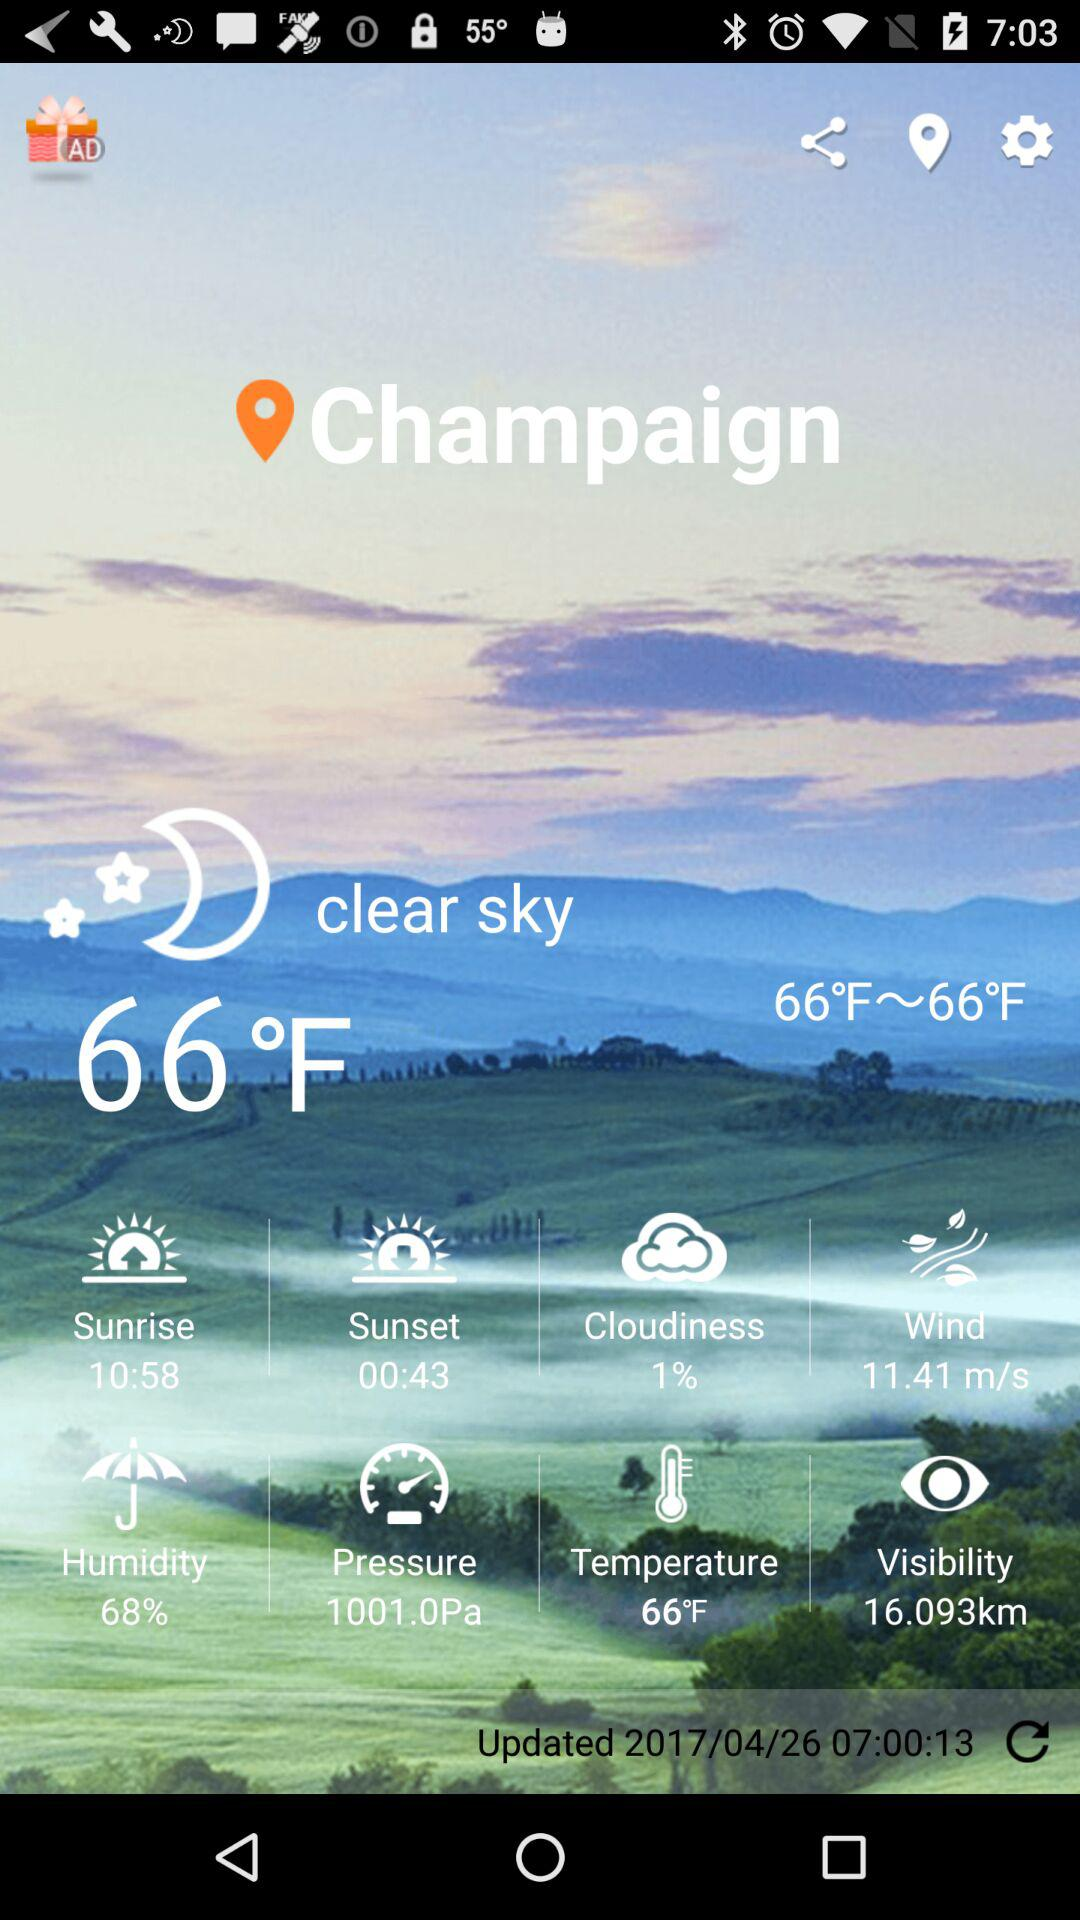What is the speed of the wind?
Answer the question using a single word or phrase. The speed of the wind is 11.41 m/s 